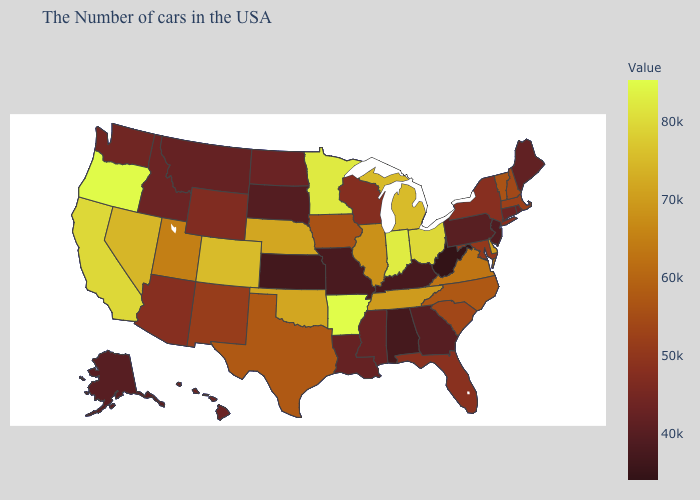Does the map have missing data?
Be succinct. No. Does the map have missing data?
Short answer required. No. Does Hawaii have the highest value in the USA?
Give a very brief answer. No. Does Alaska have the lowest value in the West?
Be succinct. Yes. Does Utah have the highest value in the West?
Quick response, please. No. 